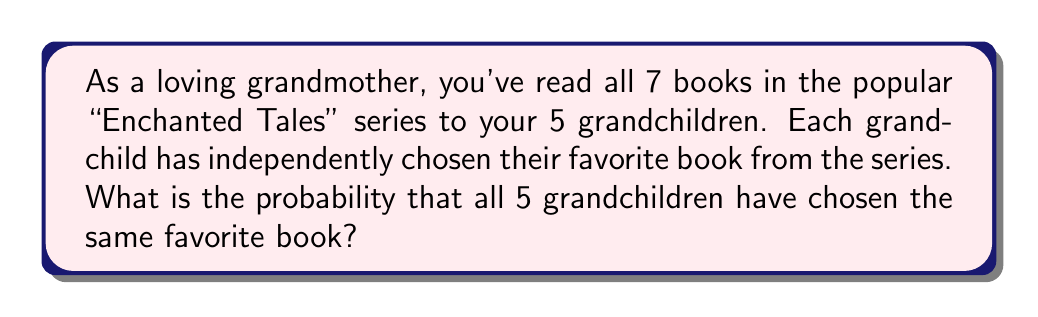Could you help me with this problem? Let's approach this step-by-step:

1) First, we need to understand what the question is asking. We're looking for the probability that all 5 grandchildren chose the same book as their favorite, out of 7 possible books.

2) This is a case where we can use the concept of equally likely outcomes. Each grandchild has an equal chance of choosing any of the 7 books as their favorite.

3) The total number of possible outcomes (total sample space) is:
   $$7^5$$
   This is because each of the 5 grandchildren has 7 choices, and we multiply these together.

4) Now, for the favorable outcomes (all choosing the same book), we can think of it this way:
   - The first grandchild can choose any of the 7 books.
   - All other grandchildren must choose the same book as the first.

5) So, the number of favorable outcomes is:
   $$7 \cdot 1 \cdot 1 \cdot 1 \cdot 1 = 7$$

6) The probability is then:

   $$P(\text{all same}) = \frac{\text{favorable outcomes}}{\text{total outcomes}} = \frac{7}{7^5} = \frac{7}{16807}$$

7) To express this as a decimal, we can divide:
   $$\frac{7}{16807} \approx 0.000416488$$

8) To express as a percentage, we multiply by 100:
   $$0.000416488 \cdot 100\% \approx 0.0416488\%$$
Answer: The probability that all 5 grandchildren have chosen the same favorite book is $\frac{7}{16807}$, or approximately 0.0416488%. 